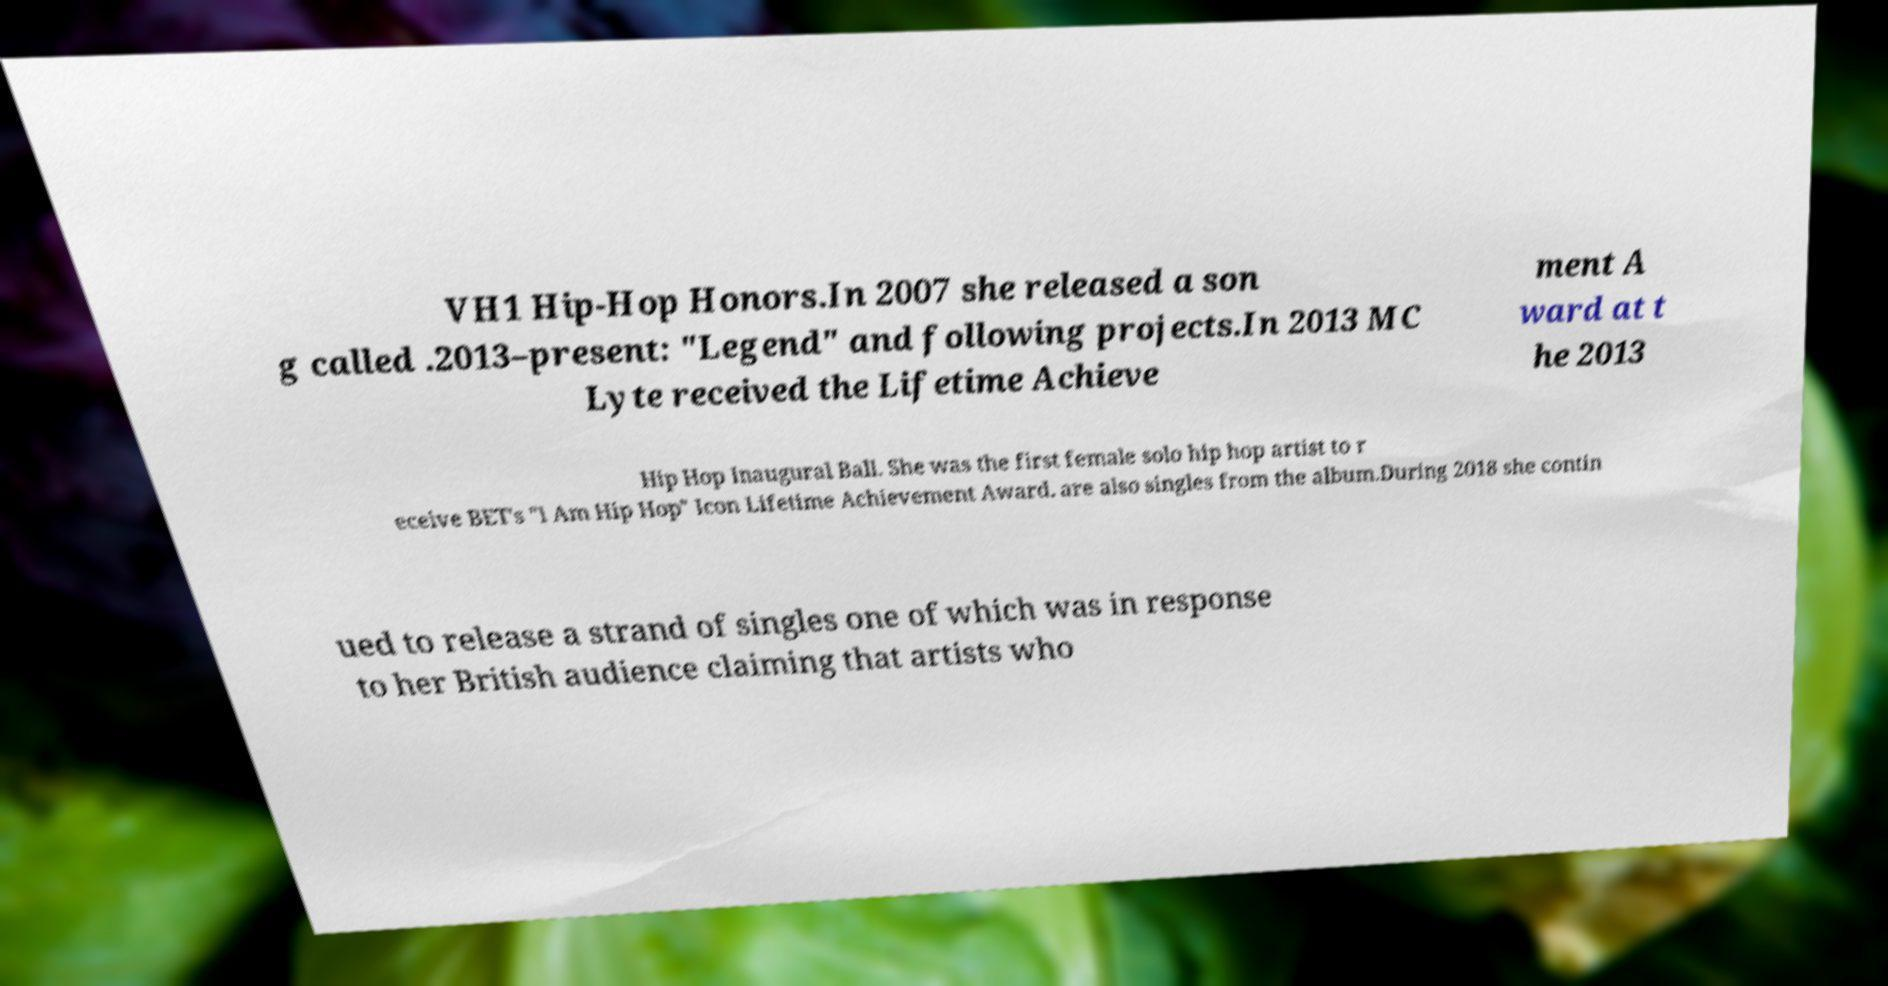Please identify and transcribe the text found in this image. VH1 Hip-Hop Honors.In 2007 she released a son g called .2013–present: "Legend" and following projects.In 2013 MC Lyte received the Lifetime Achieve ment A ward at t he 2013 Hip Hop Inaugural Ball. She was the first female solo hip hop artist to r eceive BET's "I Am Hip Hop" Icon Lifetime Achievement Award. are also singles from the album.During 2018 she contin ued to release a strand of singles one of which was in response to her British audience claiming that artists who 